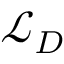<formula> <loc_0><loc_0><loc_500><loc_500>\mathcal { L } _ { D }</formula> 